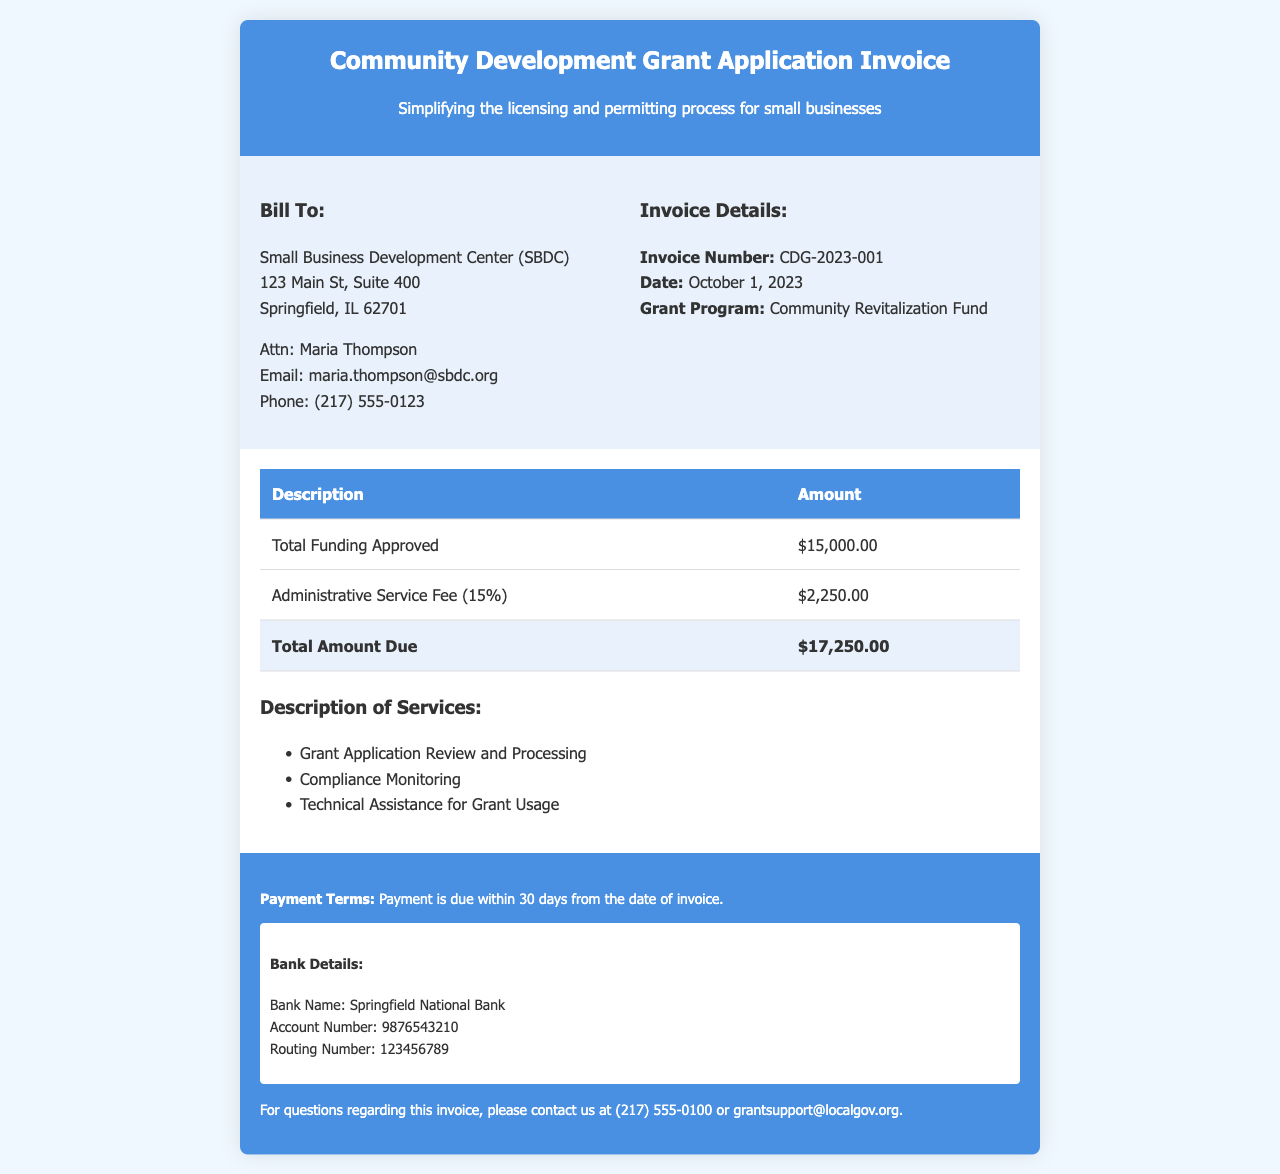what is the invoice number? The invoice number is specified in the invoice details section.
Answer: CDG-2023-001 what is the total funding approved? The total funding approved is listed in the invoice body under the description of funding.
Answer: $15,000.00 who is the recipient of the invoice? The recipient's information is provided in the "Bill To" section of the invoice.
Answer: Small Business Development Center (SBDC) what is the administrative service fee percentage? This is mentioned in the invoice body under the description of the service fee.
Answer: 15% what is the total amount due? The total amount due is calculated and presented in the invoice body.
Answer: $17,250.00 what are the payment terms? The payment terms are specified in the footer section of the invoice.
Answer: Payment is due within 30 days from the date of invoice what services are included in the description? The services provided are listed in a bullet point format in the invoice body.
Answer: Grant Application Review and Processing, Compliance Monitoring, Technical Assistance for Grant Usage who should be contacted for questions regarding the invoice? The contact information for questions is provided in the footer of the invoice.
Answer: (217) 555-0100 or grantsupport@localgov.org what is the date of the invoice? The date is specified in the invoice details section.
Answer: October 1, 2023 